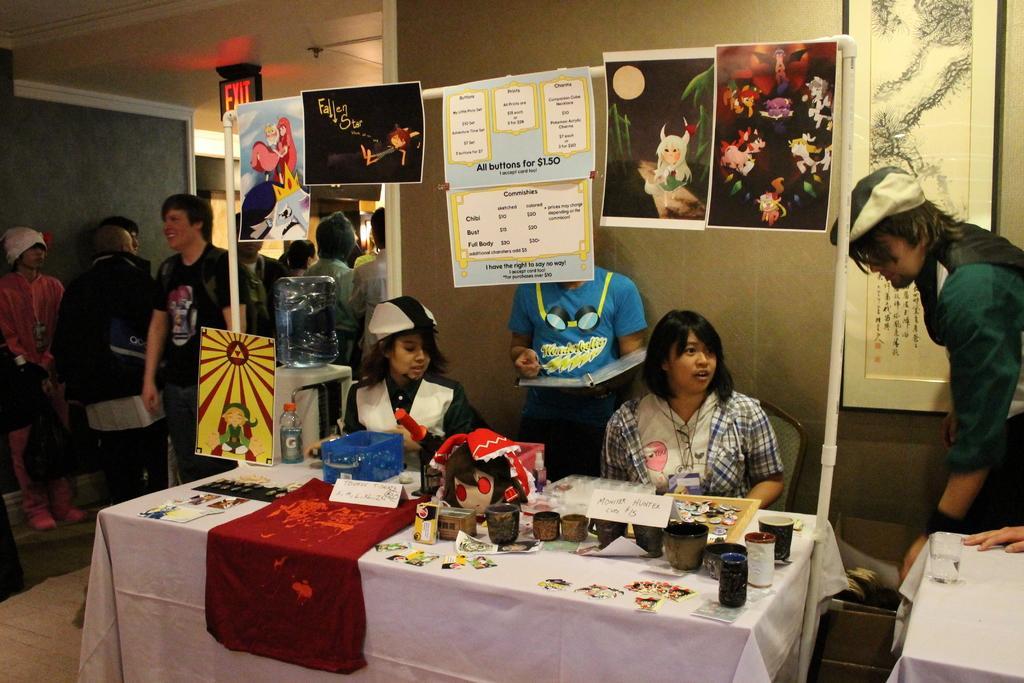How would you summarize this image in a sentence or two? As we can see in the image there is a wallpapers, table. On table there are glasses and poster and there are few people sitting and standing over here. 